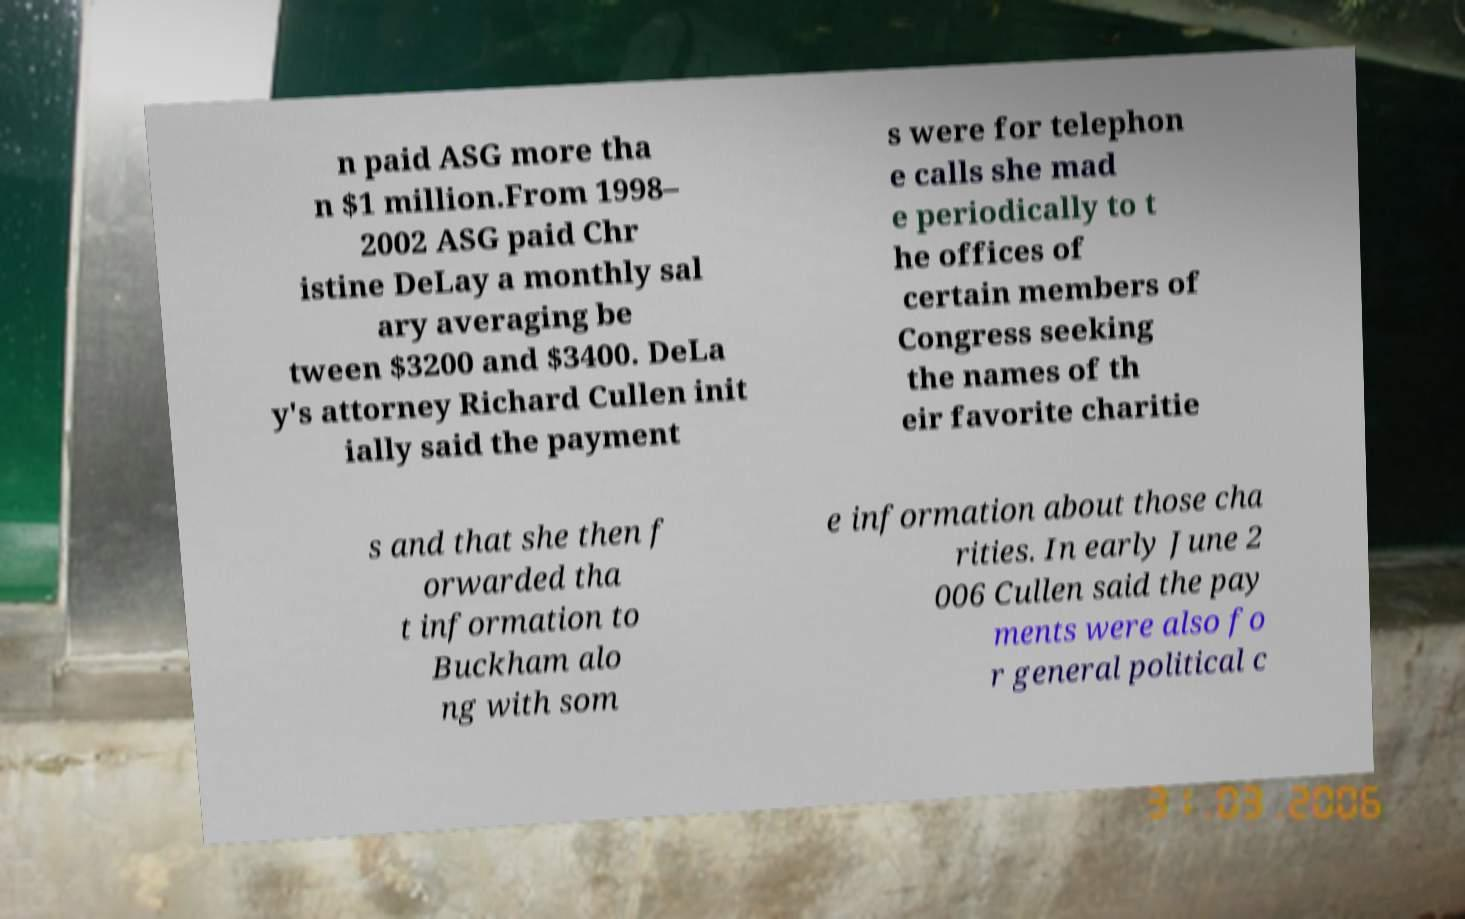I need the written content from this picture converted into text. Can you do that? n paid ASG more tha n $1 million.From 1998– 2002 ASG paid Chr istine DeLay a monthly sal ary averaging be tween $3200 and $3400. DeLa y's attorney Richard Cullen init ially said the payment s were for telephon e calls she mad e periodically to t he offices of certain members of Congress seeking the names of th eir favorite charitie s and that she then f orwarded tha t information to Buckham alo ng with som e information about those cha rities. In early June 2 006 Cullen said the pay ments were also fo r general political c 